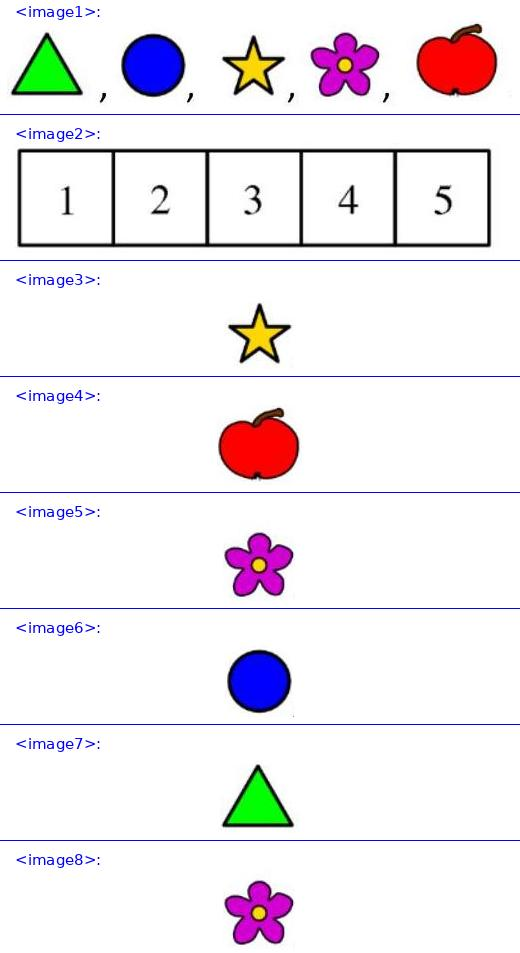Eva has the 5 stickers shown: <image1>. She stuck one of them on each of the 5 squares of this board <image2> so that <image3> (star) is not on square 5, <image4> (apple) is on square 1, and <image5> (flower) is adjacent to <image6> (circle) and <image7> (triangle). On which square did Eva stick <image5>? Eva placed the flower sticker on square 4. Here's the reasoning: The apple is in square 1, as specified. The star cannot be in square 5, so it can be in any of squares 2, 3, or 4. Since the flower must be adjacent to both the circle and the triangle, the optimal placement to satisfy this condition and still adhere to the star's placement constraint is for the flower (circle's adjacent) to be in square 4, with the circle likely in square 3 and the triangle possibly in square 5. 